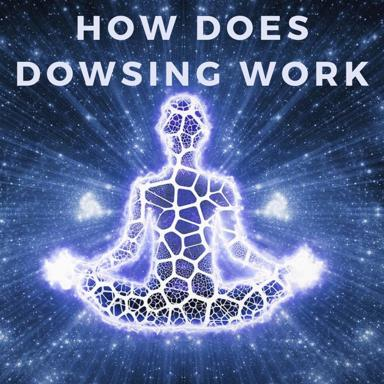What does the presence of a starry background and galaxy-like textures on the man’s body signify in a broader cultural or spiritual context? The starry background and galaxy textures symbolize a profound connection to the universe at large, reflecting notions of unity and the interconnectivity of all things. This iconography is often used in spiritual and new-age contexts to denote enlightenment or cosmic consciousness, where individuals see themselves as part of a larger, harmonious whole, transcending the physical to reach a deeper understanding of existence. Could there be a practical interpretation to these cosmic elements as well? In a practical sense, these elements might reflect humanity’s ongoing fascination and exploration of outer space, representing the limitless possibilities of discovery and expansion. They remind viewers of the human desire to explore and understand the mysteries that lie beyond our immediate sensory perceptions, much like the quest for understanding and utilizing unseen energies exemplified by dowsing. 